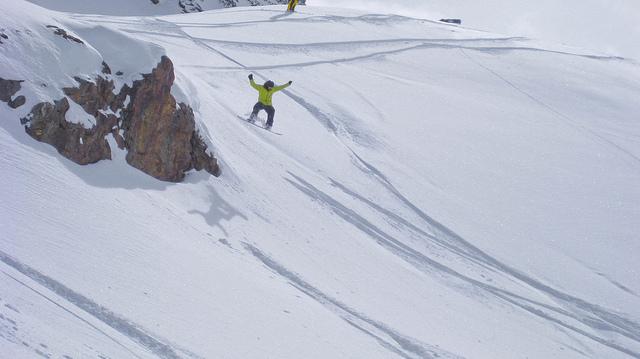Is this an artificial snow?
Be succinct. No. Is that a man or a woman?
Keep it brief. Man. What color jacket is he wearing?
Keep it brief. Yellow. 